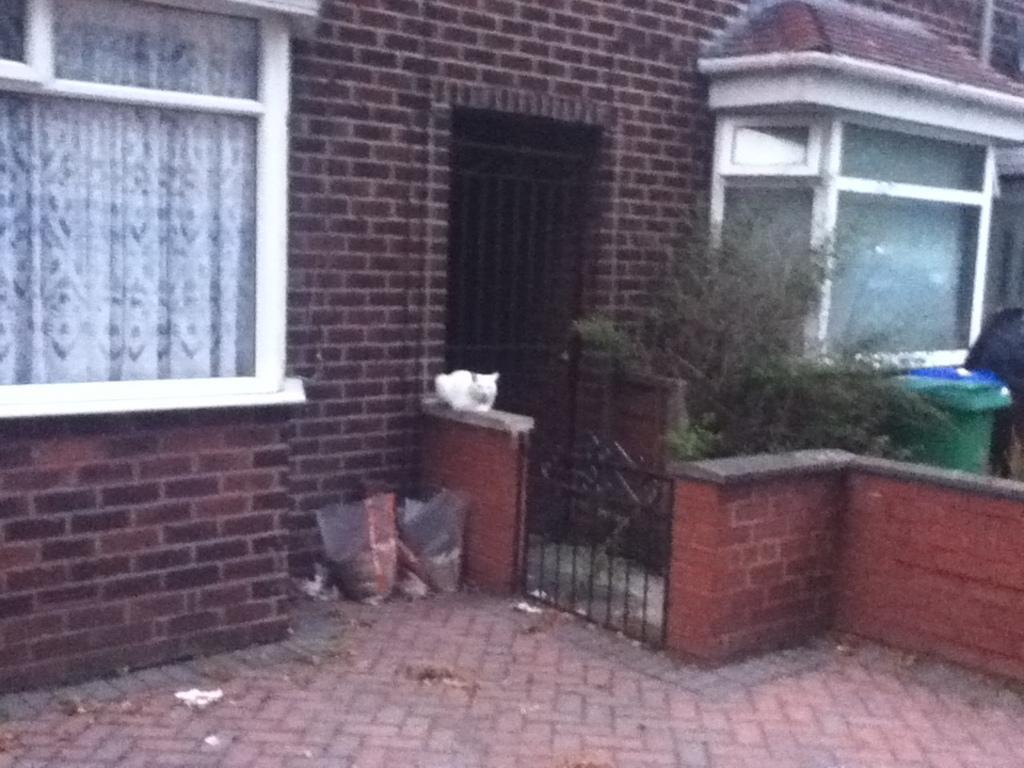What type of structures can be seen in the image? There are houses in the image. What can be seen through the window in the image? There is a window in the image, but it is not clear what can be seen through it. What is covering the window in the image? There is a curtain in the image. What is covering the furniture or objects in the image? There are covers in the image. What type of vegetation is present in the image? There are plants in the image. What type of container is visible in the image? There is a dustbin in the image. How many cherries are on the sand in the image? There is no sand or cherries present in the image. What type of town is depicted in the image? The image does not depict a town; it features houses, a window, a curtain, covers, plants, and a dustbin. 